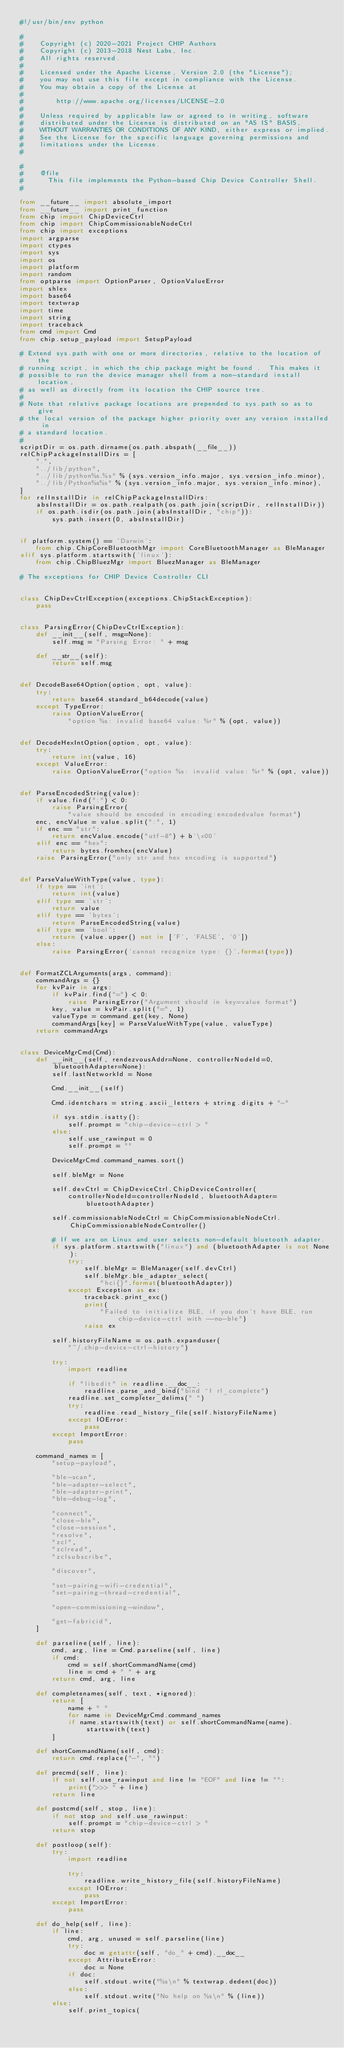Convert code to text. <code><loc_0><loc_0><loc_500><loc_500><_Python_>#!/usr/bin/env python

#
#    Copyright (c) 2020-2021 Project CHIP Authors
#    Copyright (c) 2013-2018 Nest Labs, Inc.
#    All rights reserved.
#
#    Licensed under the Apache License, Version 2.0 (the "License");
#    you may not use this file except in compliance with the License.
#    You may obtain a copy of the License at
#
#        http://www.apache.org/licenses/LICENSE-2.0
#
#    Unless required by applicable law or agreed to in writing, software
#    distributed under the License is distributed on an "AS IS" BASIS,
#    WITHOUT WARRANTIES OR CONDITIONS OF ANY KIND, either express or implied.
#    See the License for the specific language governing permissions and
#    limitations under the License.
#

#
#    @file
#      This file implements the Python-based Chip Device Controller Shell.
#

from __future__ import absolute_import
from __future__ import print_function
from chip import ChipDeviceCtrl
from chip import ChipCommissionableNodeCtrl
from chip import exceptions
import argparse
import ctypes
import sys
import os
import platform
import random
from optparse import OptionParser, OptionValueError
import shlex
import base64
import textwrap
import time
import string
import traceback
from cmd import Cmd
from chip.setup_payload import SetupPayload

# Extend sys.path with one or more directories, relative to the location of the
# running script, in which the chip package might be found .  This makes it
# possible to run the device manager shell from a non-standard install location,
# as well as directly from its location the CHIP source tree.
#
# Note that relative package locations are prepended to sys.path so as to give
# the local version of the package higher priority over any version installed in
# a standard location.
#
scriptDir = os.path.dirname(os.path.abspath(__file__))
relChipPackageInstallDirs = [
    ".",
    "../lib/python",
    "../lib/python%s.%s" % (sys.version_info.major, sys.version_info.minor),
    "../lib/Python%s%s" % (sys.version_info.major, sys.version_info.minor),
]
for relInstallDir in relChipPackageInstallDirs:
    absInstallDir = os.path.realpath(os.path.join(scriptDir, relInstallDir))
    if os.path.isdir(os.path.join(absInstallDir, "chip")):
        sys.path.insert(0, absInstallDir)


if platform.system() == 'Darwin':
    from chip.ChipCoreBluetoothMgr import CoreBluetoothManager as BleManager
elif sys.platform.startswith('linux'):
    from chip.ChipBluezMgr import BluezManager as BleManager

# The exceptions for CHIP Device Controller CLI


class ChipDevCtrlException(exceptions.ChipStackException):
    pass


class ParsingError(ChipDevCtrlException):
    def __init__(self, msg=None):
        self.msg = "Parsing Error: " + msg

    def __str__(self):
        return self.msg


def DecodeBase64Option(option, opt, value):
    try:
        return base64.standard_b64decode(value)
    except TypeError:
        raise OptionValueError(
            "option %s: invalid base64 value: %r" % (opt, value))


def DecodeHexIntOption(option, opt, value):
    try:
        return int(value, 16)
    except ValueError:
        raise OptionValueError("option %s: invalid value: %r" % (opt, value))


def ParseEncodedString(value):
    if value.find(":") < 0:
        raise ParsingError(
            "value should be encoded in encoding:encodedvalue format")
    enc, encValue = value.split(":", 1)
    if enc == "str":
        return encValue.encode("utf-8") + b'\x00'
    elif enc == "hex":
        return bytes.fromhex(encValue)
    raise ParsingError("only str and hex encoding is supported")


def ParseValueWithType(value, type):
    if type == 'int':
        return int(value)
    elif type == 'str':
        return value
    elif type == 'bytes':
        return ParseEncodedString(value)
    elif type == 'bool':
        return (value.upper() not in ['F', 'FALSE', '0'])
    else:
        raise ParsingError('cannot recognize type: {}'.format(type))


def FormatZCLArguments(args, command):
    commandArgs = {}
    for kvPair in args:
        if kvPair.find("=") < 0:
            raise ParsingError("Argument should in key=value format")
        key, value = kvPair.split("=", 1)
        valueType = command.get(key, None)
        commandArgs[key] = ParseValueWithType(value, valueType)
    return commandArgs


class DeviceMgrCmd(Cmd):
    def __init__(self, rendezvousAddr=None, controllerNodeId=0, bluetoothAdapter=None):
        self.lastNetworkId = None

        Cmd.__init__(self)

        Cmd.identchars = string.ascii_letters + string.digits + "-"

        if sys.stdin.isatty():
            self.prompt = "chip-device-ctrl > "
        else:
            self.use_rawinput = 0
            self.prompt = ""

        DeviceMgrCmd.command_names.sort()

        self.bleMgr = None

        self.devCtrl = ChipDeviceCtrl.ChipDeviceController(
            controllerNodeId=controllerNodeId, bluetoothAdapter=bluetoothAdapter)

        self.commissionableNodeCtrl = ChipCommissionableNodeCtrl.ChipCommissionableNodeController()

        # If we are on Linux and user selects non-default bluetooth adapter.
        if sys.platform.startswith("linux") and (bluetoothAdapter is not None):
            try:
                self.bleMgr = BleManager(self.devCtrl)
                self.bleMgr.ble_adapter_select(
                    "hci{}".format(bluetoothAdapter))
            except Exception as ex:
                traceback.print_exc()
                print(
                    "Failed to initialize BLE, if you don't have BLE, run chip-device-ctrl with --no-ble")
                raise ex

        self.historyFileName = os.path.expanduser(
            "~/.chip-device-ctrl-history")

        try:
            import readline

            if "libedit" in readline.__doc__:
                readline.parse_and_bind("bind ^I rl_complete")
            readline.set_completer_delims(" ")
            try:
                readline.read_history_file(self.historyFileName)
            except IOError:
                pass
        except ImportError:
            pass

    command_names = [
        "setup-payload",

        "ble-scan",
        "ble-adapter-select",
        "ble-adapter-print",
        "ble-debug-log",

        "connect",
        "close-ble",
        "close-session",
        "resolve",
        "zcl",
        "zclread",
        "zclsubscribe",

        "discover",

        "set-pairing-wifi-credential",
        "set-pairing-thread-credential",

        "open-commissioning-window",

        "get-fabricid",
    ]

    def parseline(self, line):
        cmd, arg, line = Cmd.parseline(self, line)
        if cmd:
            cmd = self.shortCommandName(cmd)
            line = cmd + " " + arg
        return cmd, arg, line

    def completenames(self, text, *ignored):
        return [
            name + " "
            for name in DeviceMgrCmd.command_names
            if name.startswith(text) or self.shortCommandName(name).startswith(text)
        ]

    def shortCommandName(self, cmd):
        return cmd.replace("-", "")

    def precmd(self, line):
        if not self.use_rawinput and line != "EOF" and line != "":
            print(">>> " + line)
        return line

    def postcmd(self, stop, line):
        if not stop and self.use_rawinput:
            self.prompt = "chip-device-ctrl > "
        return stop

    def postloop(self):
        try:
            import readline

            try:
                readline.write_history_file(self.historyFileName)
            except IOError:
                pass
        except ImportError:
            pass

    def do_help(self, line):
        if line:
            cmd, arg, unused = self.parseline(line)
            try:
                doc = getattr(self, "do_" + cmd).__doc__
            except AttributeError:
                doc = None
            if doc:
                self.stdout.write("%s\n" % textwrap.dedent(doc))
            else:
                self.stdout.write("No help on %s\n" % (line))
        else:
            self.print_topics(</code> 